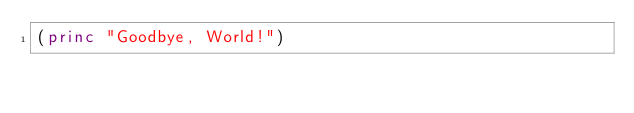Convert code to text. <code><loc_0><loc_0><loc_500><loc_500><_Lisp_>(princ "Goodbye, World!")
</code> 